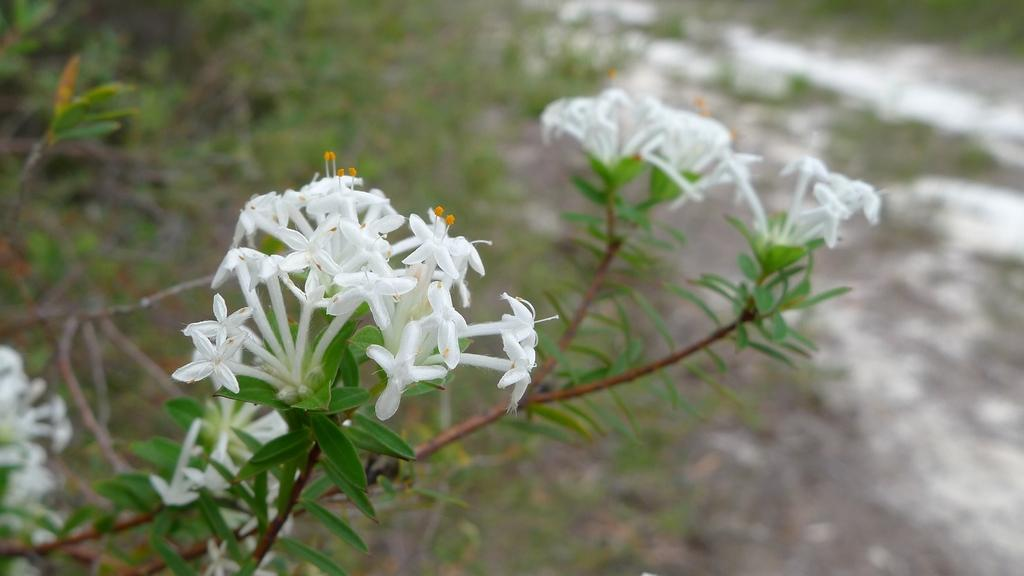What type of plants are visible in the image? There are plants with flowers in the image. What can be seen in the background of the image? The background of the image includes grass. How would you describe the appearance of the background? The background appears blurry. Where is the hose located in the image? There is no hose present in the image. What type of finger can be seen holding the parcel in the image? There is no parcel or finger present in the image. 